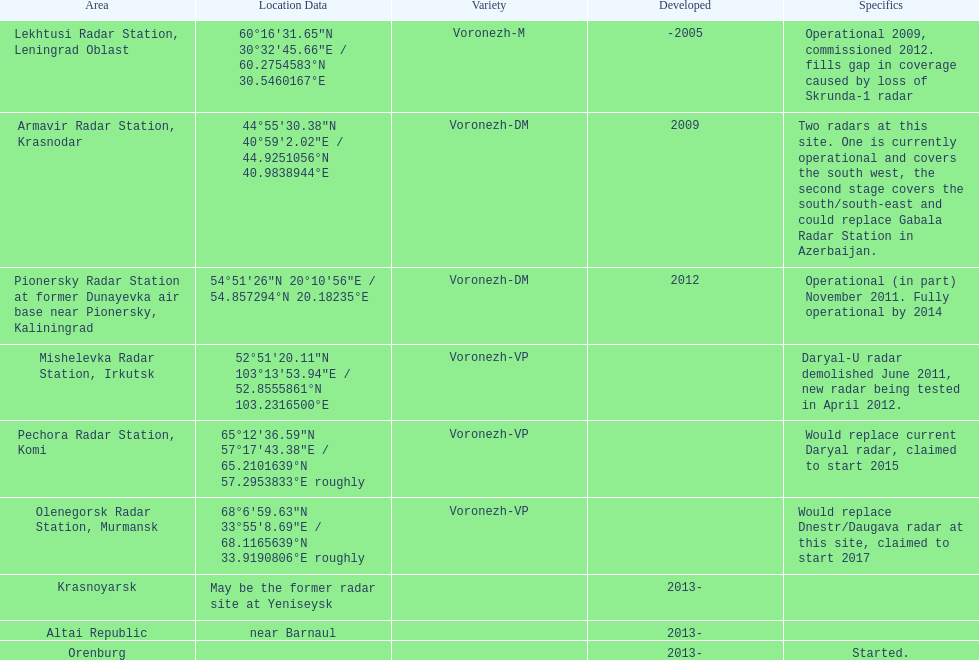How many voronezh radars are in kaliningrad or in krasnodar? 2. 